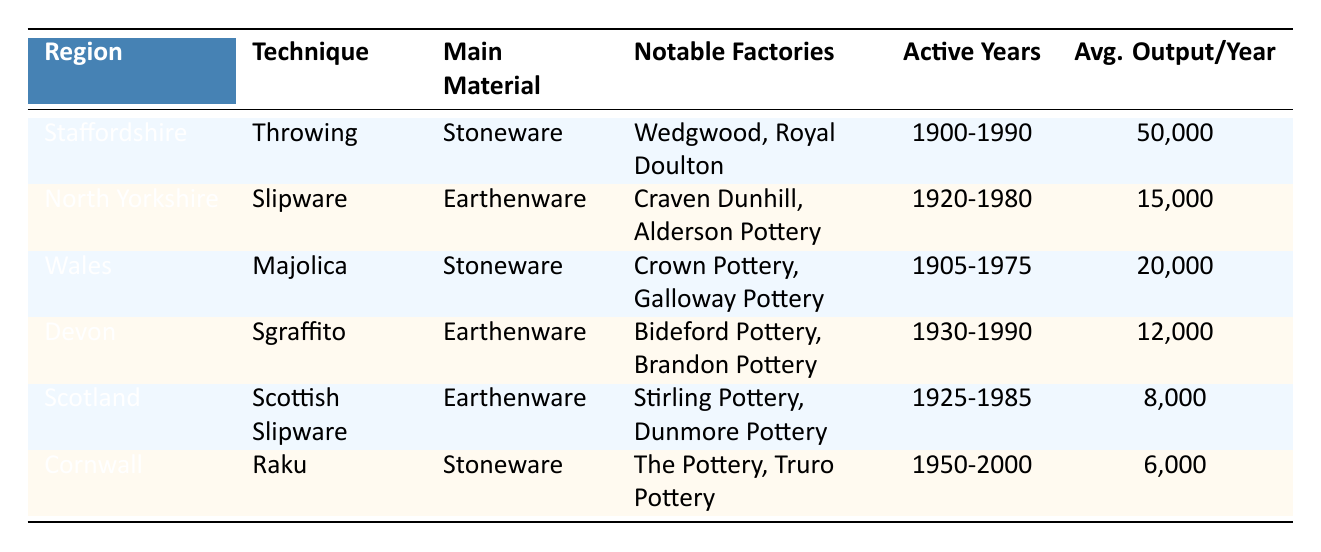What pottery production technique is used in Staffordshire? The table shows that the technique used in Staffordshire is "Throwing."
Answer: Throwing Which region has the highest average output per year? By reviewing the average output per year, Staffordshire has the highest output, which is 50,000 units.
Answer: 50,000 How many notable factories are there in Cornwall? The table lists two notable factories in Cornwall: "The Pottery" and "Truro Pottery."
Answer: 2 Is it true that Devon produces stoneware? The data indicates that Devon's main material for pottery is "Earthenware," not stoneware. Therefore, the statement is false.
Answer: No What is the combined average output per year of North Yorkshire and Wales? North Yorkshire has an average output of 15,000 units and Wales has 20,000 units. Adding these gives (15,000 + 20,000) = 35,000 units.
Answer: 35,000 In which active years was Scottish Slipware produced? The table specifies that Scottish Slipware was produced from 1925 to 1985.
Answer: 1925-1985 Which pottery technique in Wales is characterized by the main material stoneware? The technique in Wales that uses stoneware is "Majolica," as indicated in the table.
Answer: Majolica Which region had an average output less than 10,000 units per year? According to the table, Scotland and Cornwall had average outputs of 8,000 and 6,000 units respectively, both of which are less than 10,000.
Answer: Scotland and Cornwall What is the average output per year for the techniques using Earthenware? The average output for North Yorkshire is 15,000, Devon is 12,000, and Scotland is 8,000. The total is (15,000 + 12,000 + 8,000) = 35,000 units. The average is 35,000/3 = 11,667.
Answer: 11,667 